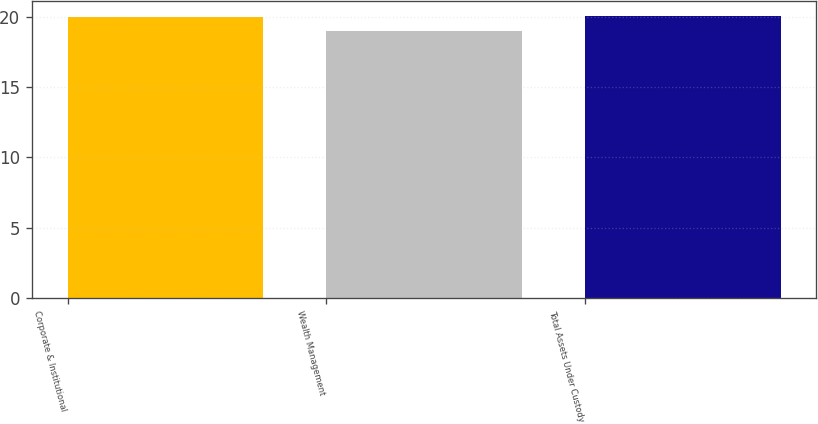Convert chart. <chart><loc_0><loc_0><loc_500><loc_500><bar_chart><fcel>Corporate & Institutional<fcel>Wealth Management<fcel>Total Assets Under Custody<nl><fcel>20<fcel>19<fcel>20.1<nl></chart> 